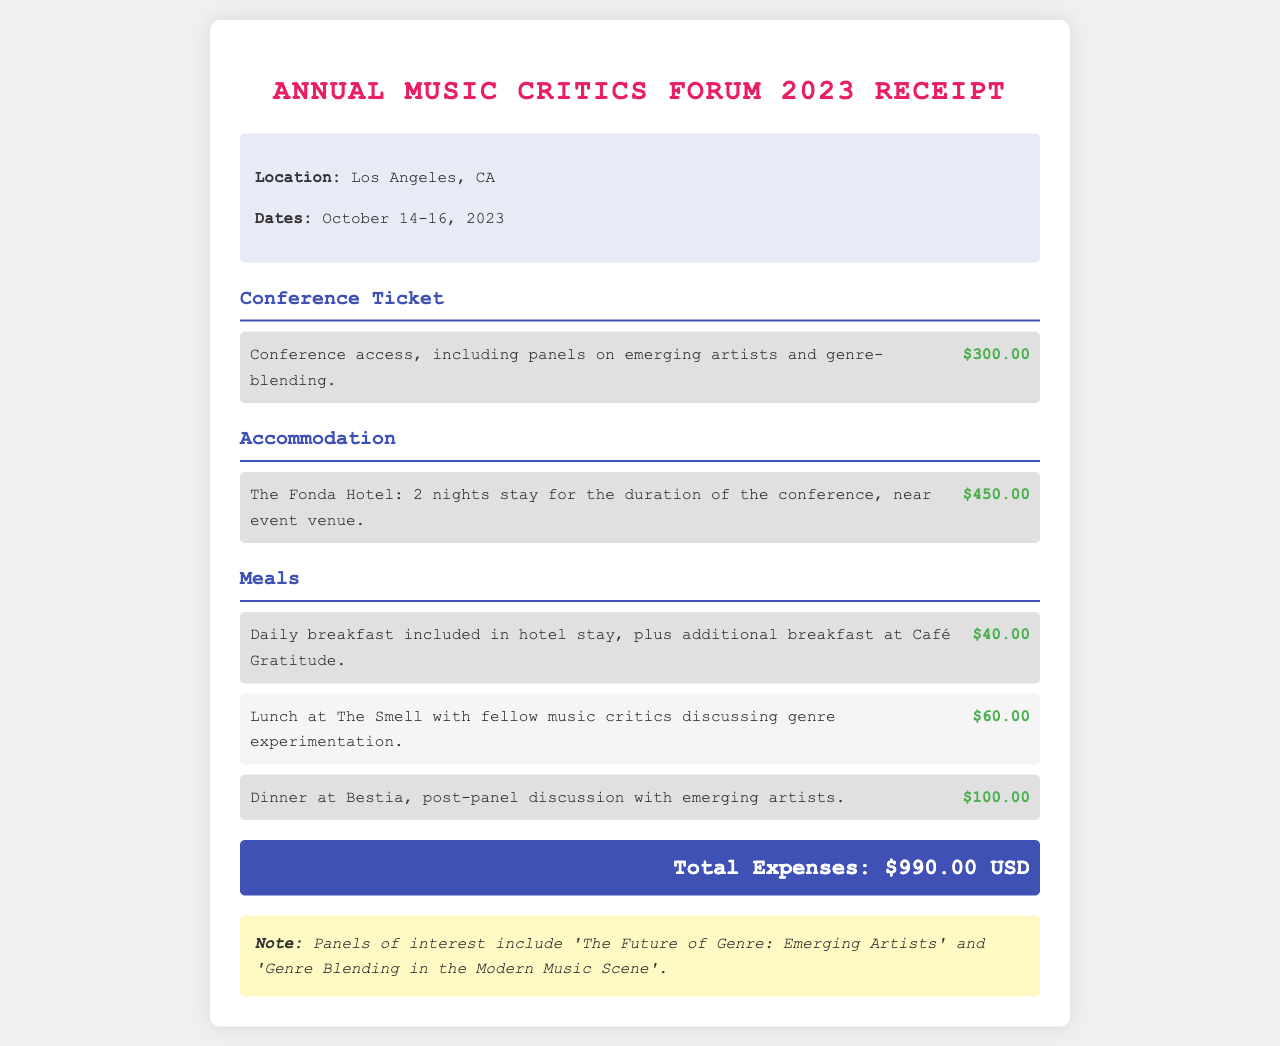What is the total amount for the conference ticket? The conference ticket amount is listed in the expense section and is $300.00.
Answer: $300.00 How many nights was accommodation booked? The accommodation information provides details about a 2-night stay at The Fonda Hotel.
Answer: 2 nights What is the location of the conference? The receipt specifies that the conference was held in Los Angeles, CA.
Answer: Los Angeles, CA What was the cost of dinner at Bestia? The expense item for dinner at Bestia indicates the cost is $100.00.
Answer: $100.00 Which hotel was used for accommodation? The accommodation details mention staying at The Fonda Hotel during the conference.
Answer: The Fonda Hotel What was the total expense for all items? The total expenses are clearly stated at the bottom of the receipt as $990.00 USD.
Answer: $990.00 USD What panels discussed genre blending? The notes mention panels of interest, specifically 'The Future of Genre: Emerging Artists' and 'Genre Blending in the Modern Music Scene'.
Answer: 'The Future of Genre: Emerging Artists' and 'Genre Blending in the Modern Music Scene' How much was spent on lunch? The lunch expense at The Smell is listed as $60.00 in the meals section.
Answer: $60.00 What is included in the hotel stay? The meals section notes that daily breakfast was included as part of the hotel stay.
Answer: Daily breakfast 